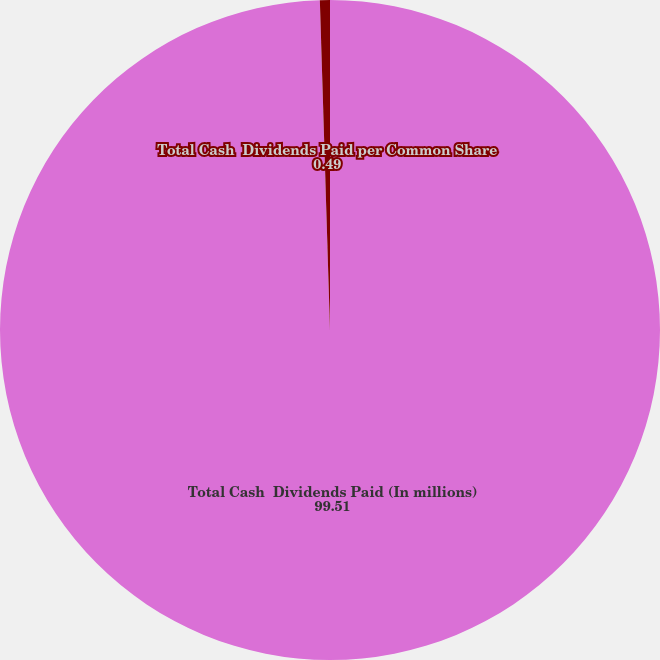<chart> <loc_0><loc_0><loc_500><loc_500><pie_chart><fcel>Total Cash  Dividends Paid (In millions)<fcel>Total Cash  Dividends Paid per Common Share<nl><fcel>99.51%<fcel>0.49%<nl></chart> 